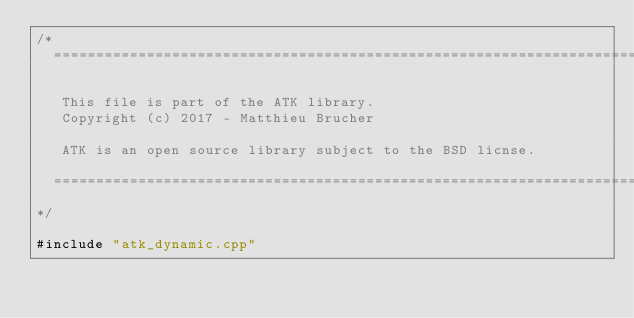Convert code to text. <code><loc_0><loc_0><loc_500><loc_500><_ObjectiveC_>/*
  ==============================================================================

   This file is part of the ATK library.
   Copyright (c) 2017 - Matthieu Brucher

   ATK is an open source library subject to the BSD licnse.

  ==============================================================================
*/

#include "atk_dynamic.cpp"
</code> 